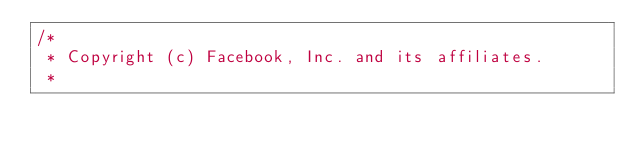<code> <loc_0><loc_0><loc_500><loc_500><_ObjectiveC_>/*
 * Copyright (c) Facebook, Inc. and its affiliates.
 *</code> 